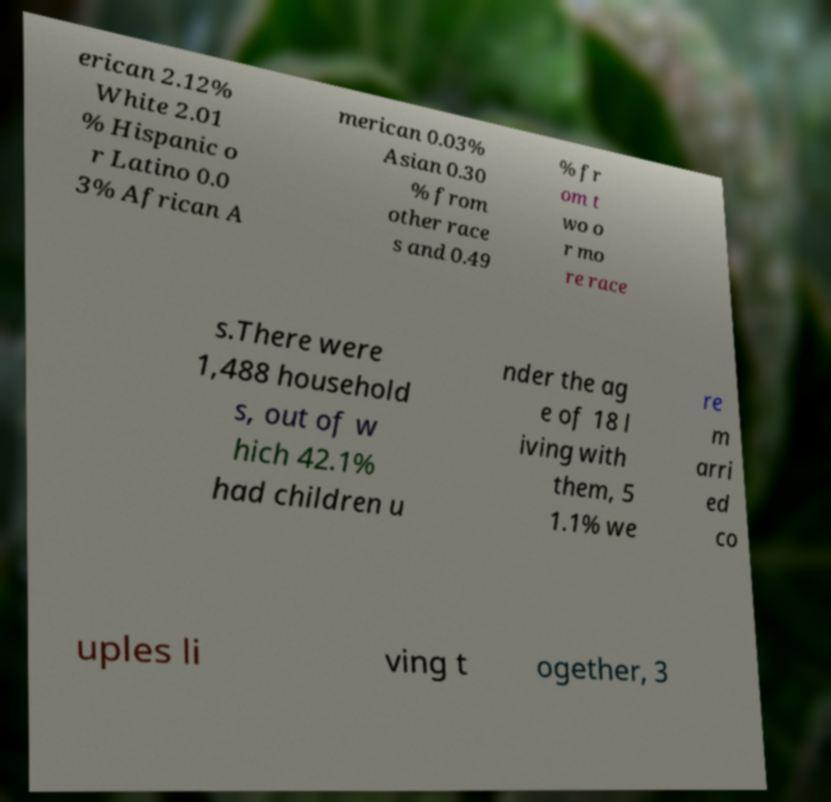I need the written content from this picture converted into text. Can you do that? erican 2.12% White 2.01 % Hispanic o r Latino 0.0 3% African A merican 0.03% Asian 0.30 % from other race s and 0.49 % fr om t wo o r mo re race s.There were 1,488 household s, out of w hich 42.1% had children u nder the ag e of 18 l iving with them, 5 1.1% we re m arri ed co uples li ving t ogether, 3 